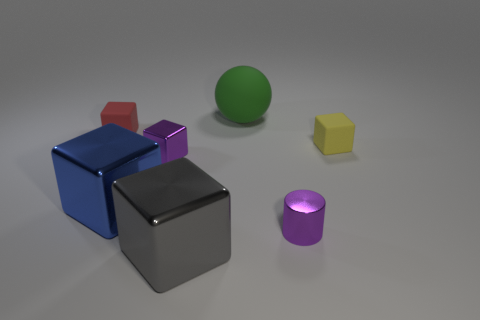Does the large block that is behind the gray metal object have the same material as the big thing behind the red thing? Based on the visual qualities observed in the image, it appears that the large block behind the gray metal object, which seems to have a reflective and smooth surface, and the big thing behind the red block, which also exhibits a similar sheen and texture, are likely made of the same or very similar materials, possibly a type of polished metal or a material with metallic properties. 